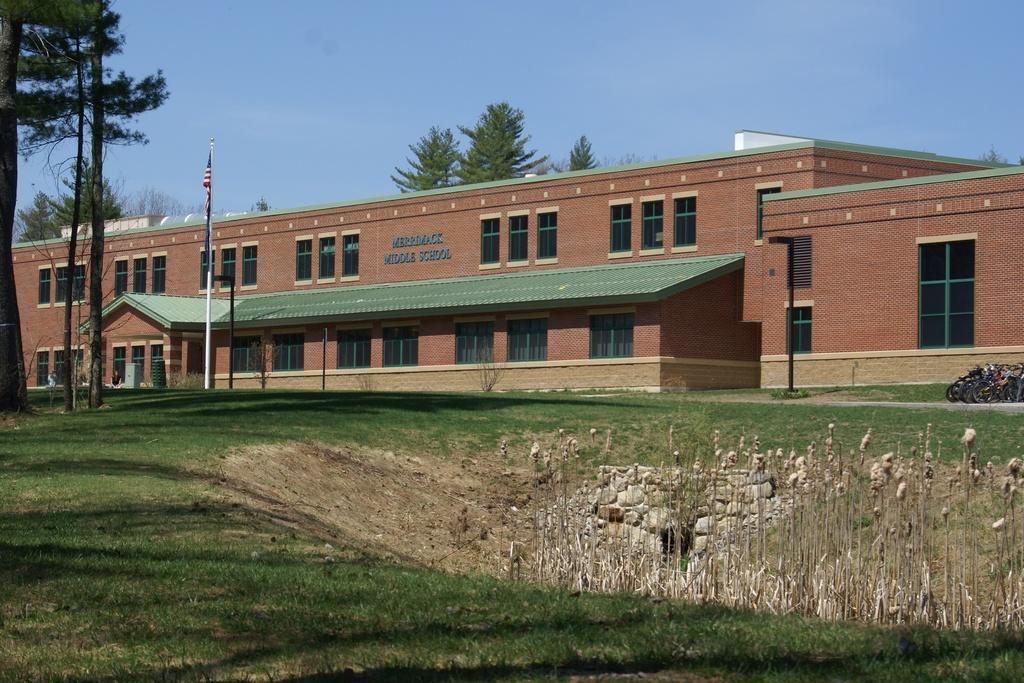What type of natural environment is visible in the image? There is grass, plants, stones, trees, and the sky visible in the image, which suggests a natural environment. What structures can be seen in the background of the image? There is a building, poles, and a flag in the background of the image. How many different types of vegetation can be seen in the image? There are plants and trees visible in the image, making a total of two types of vegetation. What type of wood is used to construct the market in the image? There is no market present in the image, so it is not possible to determine what type of wood might be used in its construction. 